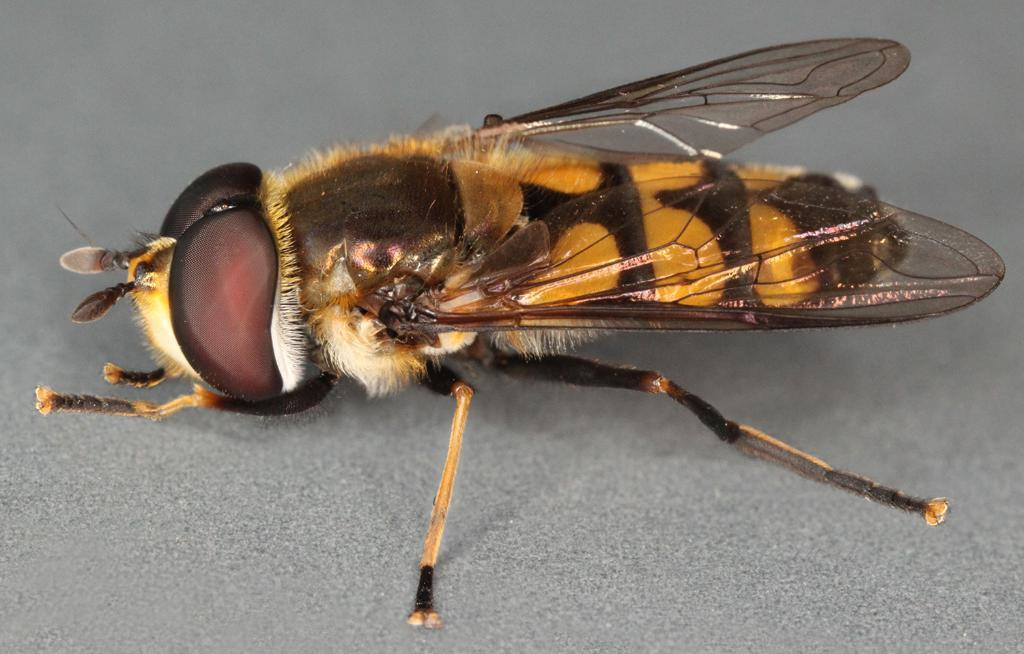What type of creature is present in the image? There is an insect in the image. Where is the insect located in the image? The insect is on the floor. How does the insect provide support to the elderly in the image? There is no elderly person or indication of support in the image; it only features an insect on the floor. 